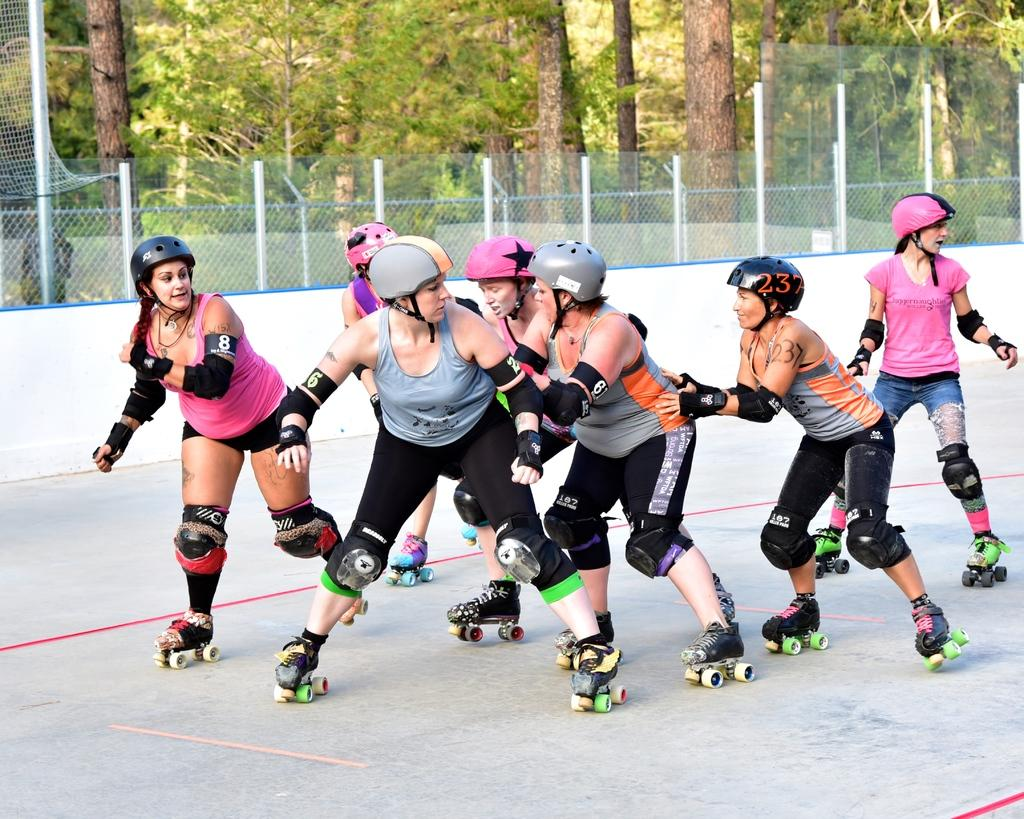What are the people in the image doing? The people in the image are skating. What can be seen in the background of the image? There is a fence and trees in the background of the background of the image. What is the surface on which the people are skating? There is a floor visible in the image. What type of pleasure can be seen in the image? There is no specific pleasure mentioned or depicted in the image; it shows a group of people skating. Is there a balloon visible in the image? No, there is no balloon present in the image. 